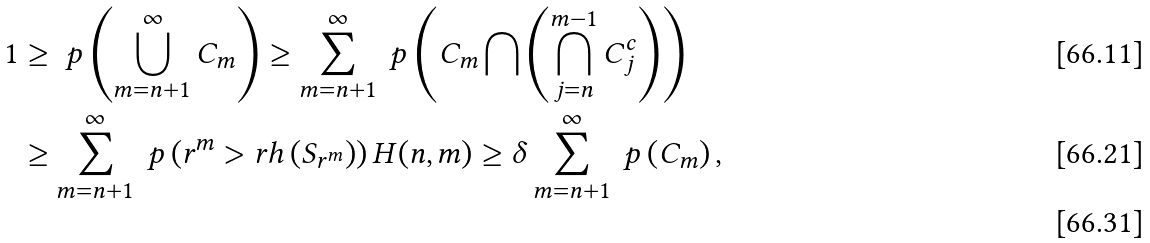<formula> <loc_0><loc_0><loc_500><loc_500>1 & \geq \ p \left ( \bigcup _ { m = n + 1 } ^ { \infty } C _ { m } \right ) \geq \sum _ { m = n + 1 } ^ { \infty } \ p \left ( C _ { m } \bigcap \left ( \bigcap _ { j = n } ^ { m - 1 } C ^ { c } _ { j } \right ) \right ) \\ & \geq \sum _ { m = n + 1 } ^ { \infty } \ p \left ( r ^ { m } > r h \left ( S _ { r ^ { m } } \right ) \right ) H ( n , m ) \geq \delta \sum _ { m = n + 1 } ^ { \infty } \ p \left ( C _ { m } \right ) , \\</formula> 